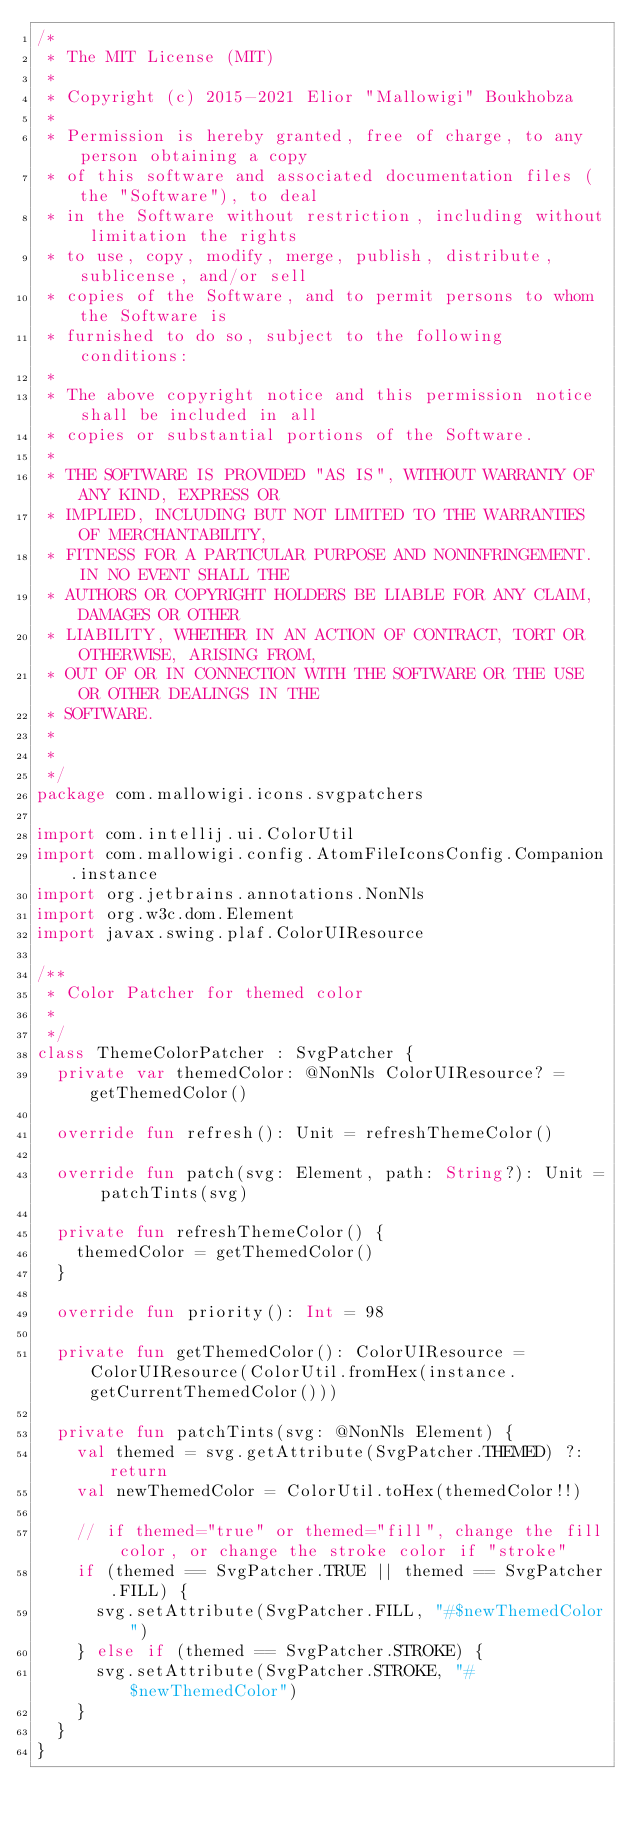Convert code to text. <code><loc_0><loc_0><loc_500><loc_500><_Kotlin_>/*
 * The MIT License (MIT)
 *
 * Copyright (c) 2015-2021 Elior "Mallowigi" Boukhobza
 *
 * Permission is hereby granted, free of charge, to any person obtaining a copy
 * of this software and associated documentation files (the "Software"), to deal
 * in the Software without restriction, including without limitation the rights
 * to use, copy, modify, merge, publish, distribute, sublicense, and/or sell
 * copies of the Software, and to permit persons to whom the Software is
 * furnished to do so, subject to the following conditions:
 *
 * The above copyright notice and this permission notice shall be included in all
 * copies or substantial portions of the Software.
 *
 * THE SOFTWARE IS PROVIDED "AS IS", WITHOUT WARRANTY OF ANY KIND, EXPRESS OR
 * IMPLIED, INCLUDING BUT NOT LIMITED TO THE WARRANTIES OF MERCHANTABILITY,
 * FITNESS FOR A PARTICULAR PURPOSE AND NONINFRINGEMENT. IN NO EVENT SHALL THE
 * AUTHORS OR COPYRIGHT HOLDERS BE LIABLE FOR ANY CLAIM, DAMAGES OR OTHER
 * LIABILITY, WHETHER IN AN ACTION OF CONTRACT, TORT OR OTHERWISE, ARISING FROM,
 * OUT OF OR IN CONNECTION WITH THE SOFTWARE OR THE USE OR OTHER DEALINGS IN THE
 * SOFTWARE.
 *
 *
 */
package com.mallowigi.icons.svgpatchers

import com.intellij.ui.ColorUtil
import com.mallowigi.config.AtomFileIconsConfig.Companion.instance
import org.jetbrains.annotations.NonNls
import org.w3c.dom.Element
import javax.swing.plaf.ColorUIResource

/**
 * Color Patcher for themed color
 *
 */
class ThemeColorPatcher : SvgPatcher {
  private var themedColor: @NonNls ColorUIResource? = getThemedColor()

  override fun refresh(): Unit = refreshThemeColor()

  override fun patch(svg: Element, path: String?): Unit = patchTints(svg)

  private fun refreshThemeColor() {
    themedColor = getThemedColor()
  }

  override fun priority(): Int = 98

  private fun getThemedColor(): ColorUIResource = ColorUIResource(ColorUtil.fromHex(instance.getCurrentThemedColor()))

  private fun patchTints(svg: @NonNls Element) {
    val themed = svg.getAttribute(SvgPatcher.THEMED) ?: return
    val newThemedColor = ColorUtil.toHex(themedColor!!)

    // if themed="true" or themed="fill", change the fill color, or change the stroke color if "stroke"
    if (themed == SvgPatcher.TRUE || themed == SvgPatcher.FILL) {
      svg.setAttribute(SvgPatcher.FILL, "#$newThemedColor")
    } else if (themed == SvgPatcher.STROKE) {
      svg.setAttribute(SvgPatcher.STROKE, "#$newThemedColor")
    }
  }
}
</code> 